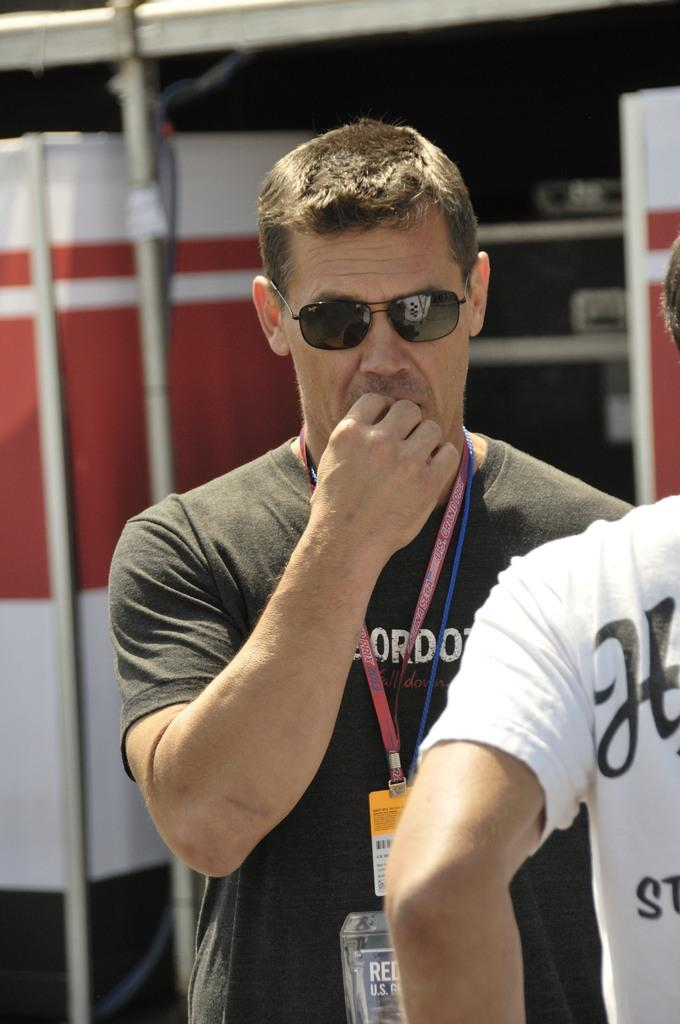<image>
Create a compact narrative representing the image presented. The guy with the sunglasses is wearing a badge with U.S. on it. 